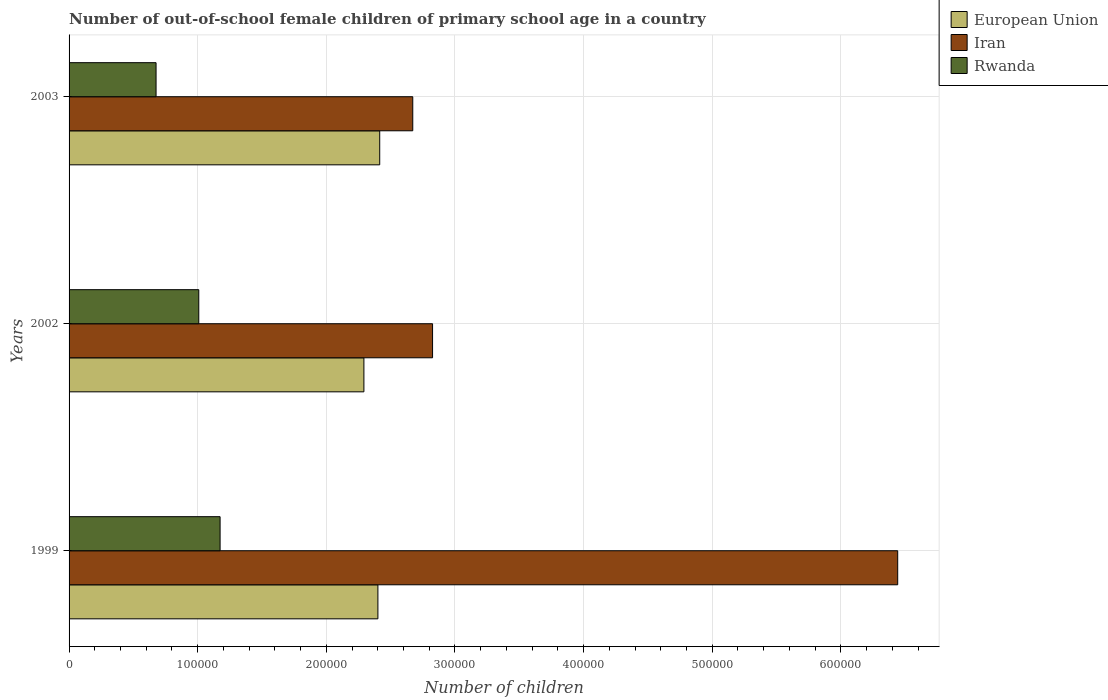How many different coloured bars are there?
Provide a short and direct response. 3. Are the number of bars per tick equal to the number of legend labels?
Ensure brevity in your answer.  Yes. What is the label of the 1st group of bars from the top?
Ensure brevity in your answer.  2003. In how many cases, is the number of bars for a given year not equal to the number of legend labels?
Make the answer very short. 0. What is the number of out-of-school female children in Iran in 2003?
Make the answer very short. 2.67e+05. Across all years, what is the maximum number of out-of-school female children in Rwanda?
Provide a short and direct response. 1.17e+05. Across all years, what is the minimum number of out-of-school female children in Iran?
Offer a terse response. 2.67e+05. In which year was the number of out-of-school female children in Rwanda maximum?
Provide a succinct answer. 1999. What is the total number of out-of-school female children in Rwanda in the graph?
Your answer should be very brief. 2.86e+05. What is the difference between the number of out-of-school female children in Iran in 2002 and that in 2003?
Offer a very short reply. 1.54e+04. What is the difference between the number of out-of-school female children in Rwanda in 1999 and the number of out-of-school female children in Iran in 2002?
Your response must be concise. -1.65e+05. What is the average number of out-of-school female children in European Union per year?
Provide a succinct answer. 2.37e+05. In the year 2003, what is the difference between the number of out-of-school female children in European Union and number of out-of-school female children in Iran?
Keep it short and to the point. -2.57e+04. In how many years, is the number of out-of-school female children in Iran greater than 300000 ?
Your response must be concise. 1. What is the ratio of the number of out-of-school female children in Iran in 2002 to that in 2003?
Ensure brevity in your answer.  1.06. Is the number of out-of-school female children in Iran in 1999 less than that in 2002?
Keep it short and to the point. No. What is the difference between the highest and the second highest number of out-of-school female children in Rwanda?
Offer a very short reply. 1.66e+04. What is the difference between the highest and the lowest number of out-of-school female children in Rwanda?
Give a very brief answer. 4.98e+04. What does the 2nd bar from the bottom in 2003 represents?
Provide a succinct answer. Iran. Are the values on the major ticks of X-axis written in scientific E-notation?
Your response must be concise. No. Where does the legend appear in the graph?
Your answer should be very brief. Top right. How many legend labels are there?
Keep it short and to the point. 3. How are the legend labels stacked?
Your answer should be very brief. Vertical. What is the title of the graph?
Make the answer very short. Number of out-of-school female children of primary school age in a country. What is the label or title of the X-axis?
Provide a short and direct response. Number of children. What is the label or title of the Y-axis?
Your answer should be compact. Years. What is the Number of children in European Union in 1999?
Give a very brief answer. 2.40e+05. What is the Number of children of Iran in 1999?
Your answer should be compact. 6.44e+05. What is the Number of children of Rwanda in 1999?
Your response must be concise. 1.17e+05. What is the Number of children in European Union in 2002?
Offer a terse response. 2.29e+05. What is the Number of children of Iran in 2002?
Your response must be concise. 2.83e+05. What is the Number of children of Rwanda in 2002?
Keep it short and to the point. 1.01e+05. What is the Number of children in European Union in 2003?
Make the answer very short. 2.41e+05. What is the Number of children of Iran in 2003?
Provide a succinct answer. 2.67e+05. What is the Number of children of Rwanda in 2003?
Provide a short and direct response. 6.76e+04. Across all years, what is the maximum Number of children in European Union?
Offer a terse response. 2.41e+05. Across all years, what is the maximum Number of children in Iran?
Offer a terse response. 6.44e+05. Across all years, what is the maximum Number of children of Rwanda?
Your answer should be very brief. 1.17e+05. Across all years, what is the minimum Number of children of European Union?
Offer a terse response. 2.29e+05. Across all years, what is the minimum Number of children of Iran?
Keep it short and to the point. 2.67e+05. Across all years, what is the minimum Number of children of Rwanda?
Provide a short and direct response. 6.76e+04. What is the total Number of children of European Union in the graph?
Your response must be concise. 7.11e+05. What is the total Number of children of Iran in the graph?
Provide a short and direct response. 1.19e+06. What is the total Number of children in Rwanda in the graph?
Keep it short and to the point. 2.86e+05. What is the difference between the Number of children of European Union in 1999 and that in 2002?
Your response must be concise. 1.09e+04. What is the difference between the Number of children in Iran in 1999 and that in 2002?
Ensure brevity in your answer.  3.62e+05. What is the difference between the Number of children of Rwanda in 1999 and that in 2002?
Ensure brevity in your answer.  1.66e+04. What is the difference between the Number of children in European Union in 1999 and that in 2003?
Your answer should be very brief. -1399. What is the difference between the Number of children in Iran in 1999 and that in 2003?
Ensure brevity in your answer.  3.77e+05. What is the difference between the Number of children in Rwanda in 1999 and that in 2003?
Give a very brief answer. 4.98e+04. What is the difference between the Number of children of European Union in 2002 and that in 2003?
Make the answer very short. -1.23e+04. What is the difference between the Number of children in Iran in 2002 and that in 2003?
Your response must be concise. 1.54e+04. What is the difference between the Number of children of Rwanda in 2002 and that in 2003?
Your answer should be very brief. 3.32e+04. What is the difference between the Number of children of European Union in 1999 and the Number of children of Iran in 2002?
Give a very brief answer. -4.25e+04. What is the difference between the Number of children in European Union in 1999 and the Number of children in Rwanda in 2002?
Offer a terse response. 1.39e+05. What is the difference between the Number of children in Iran in 1999 and the Number of children in Rwanda in 2002?
Keep it short and to the point. 5.43e+05. What is the difference between the Number of children of European Union in 1999 and the Number of children of Iran in 2003?
Provide a succinct answer. -2.71e+04. What is the difference between the Number of children in European Union in 1999 and the Number of children in Rwanda in 2003?
Your answer should be compact. 1.72e+05. What is the difference between the Number of children in Iran in 1999 and the Number of children in Rwanda in 2003?
Offer a terse response. 5.77e+05. What is the difference between the Number of children of European Union in 2002 and the Number of children of Iran in 2003?
Make the answer very short. -3.80e+04. What is the difference between the Number of children in European Union in 2002 and the Number of children in Rwanda in 2003?
Provide a short and direct response. 1.62e+05. What is the difference between the Number of children of Iran in 2002 and the Number of children of Rwanda in 2003?
Give a very brief answer. 2.15e+05. What is the average Number of children in European Union per year?
Your answer should be very brief. 2.37e+05. What is the average Number of children in Iran per year?
Your answer should be compact. 3.98e+05. What is the average Number of children of Rwanda per year?
Your answer should be compact. 9.53e+04. In the year 1999, what is the difference between the Number of children in European Union and Number of children in Iran?
Ensure brevity in your answer.  -4.04e+05. In the year 1999, what is the difference between the Number of children of European Union and Number of children of Rwanda?
Your response must be concise. 1.23e+05. In the year 1999, what is the difference between the Number of children of Iran and Number of children of Rwanda?
Provide a short and direct response. 5.27e+05. In the year 2002, what is the difference between the Number of children in European Union and Number of children in Iran?
Keep it short and to the point. -5.34e+04. In the year 2002, what is the difference between the Number of children in European Union and Number of children in Rwanda?
Offer a terse response. 1.28e+05. In the year 2002, what is the difference between the Number of children in Iran and Number of children in Rwanda?
Your answer should be very brief. 1.82e+05. In the year 2003, what is the difference between the Number of children in European Union and Number of children in Iran?
Offer a terse response. -2.57e+04. In the year 2003, what is the difference between the Number of children of European Union and Number of children of Rwanda?
Provide a short and direct response. 1.74e+05. In the year 2003, what is the difference between the Number of children of Iran and Number of children of Rwanda?
Make the answer very short. 2.00e+05. What is the ratio of the Number of children of European Union in 1999 to that in 2002?
Give a very brief answer. 1.05. What is the ratio of the Number of children in Iran in 1999 to that in 2002?
Keep it short and to the point. 2.28. What is the ratio of the Number of children of Rwanda in 1999 to that in 2002?
Give a very brief answer. 1.16. What is the ratio of the Number of children of European Union in 1999 to that in 2003?
Provide a short and direct response. 0.99. What is the ratio of the Number of children in Iran in 1999 to that in 2003?
Your answer should be very brief. 2.41. What is the ratio of the Number of children in Rwanda in 1999 to that in 2003?
Keep it short and to the point. 1.74. What is the ratio of the Number of children in European Union in 2002 to that in 2003?
Provide a short and direct response. 0.95. What is the ratio of the Number of children in Iran in 2002 to that in 2003?
Provide a short and direct response. 1.06. What is the ratio of the Number of children in Rwanda in 2002 to that in 2003?
Your answer should be compact. 1.49. What is the difference between the highest and the second highest Number of children in European Union?
Offer a very short reply. 1399. What is the difference between the highest and the second highest Number of children of Iran?
Your response must be concise. 3.62e+05. What is the difference between the highest and the second highest Number of children of Rwanda?
Ensure brevity in your answer.  1.66e+04. What is the difference between the highest and the lowest Number of children of European Union?
Your response must be concise. 1.23e+04. What is the difference between the highest and the lowest Number of children of Iran?
Offer a terse response. 3.77e+05. What is the difference between the highest and the lowest Number of children in Rwanda?
Give a very brief answer. 4.98e+04. 